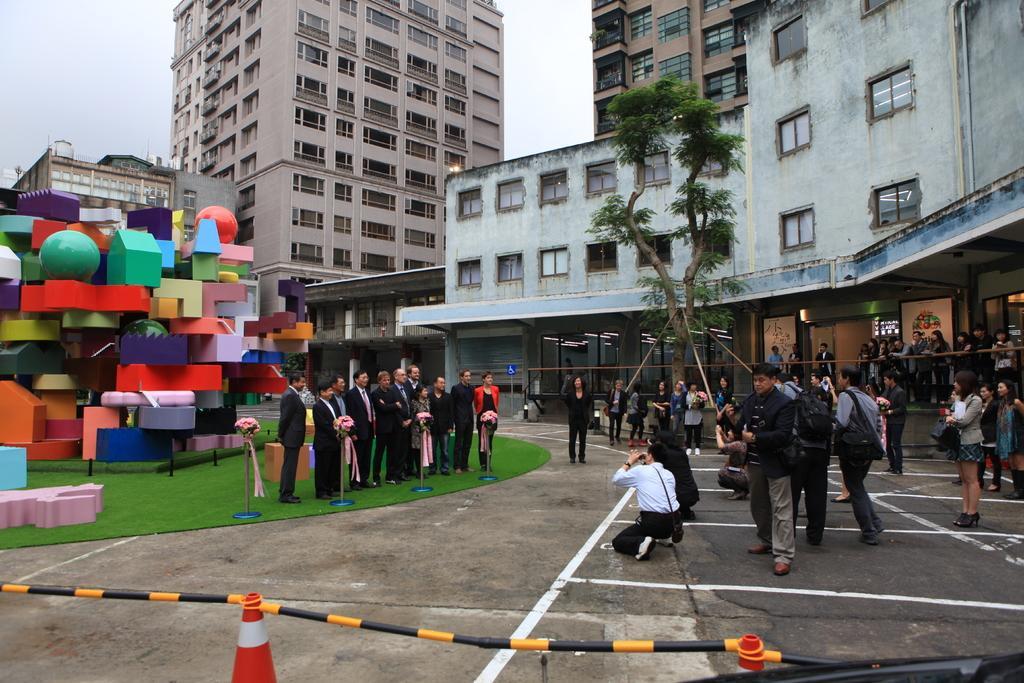Could you give a brief overview of what you see in this image? In this image I can see the ground, number of persons standing, some grass, few traffic poles, few buildings, few lights, few trees and few colorful objects. In the background I can see the sky. 